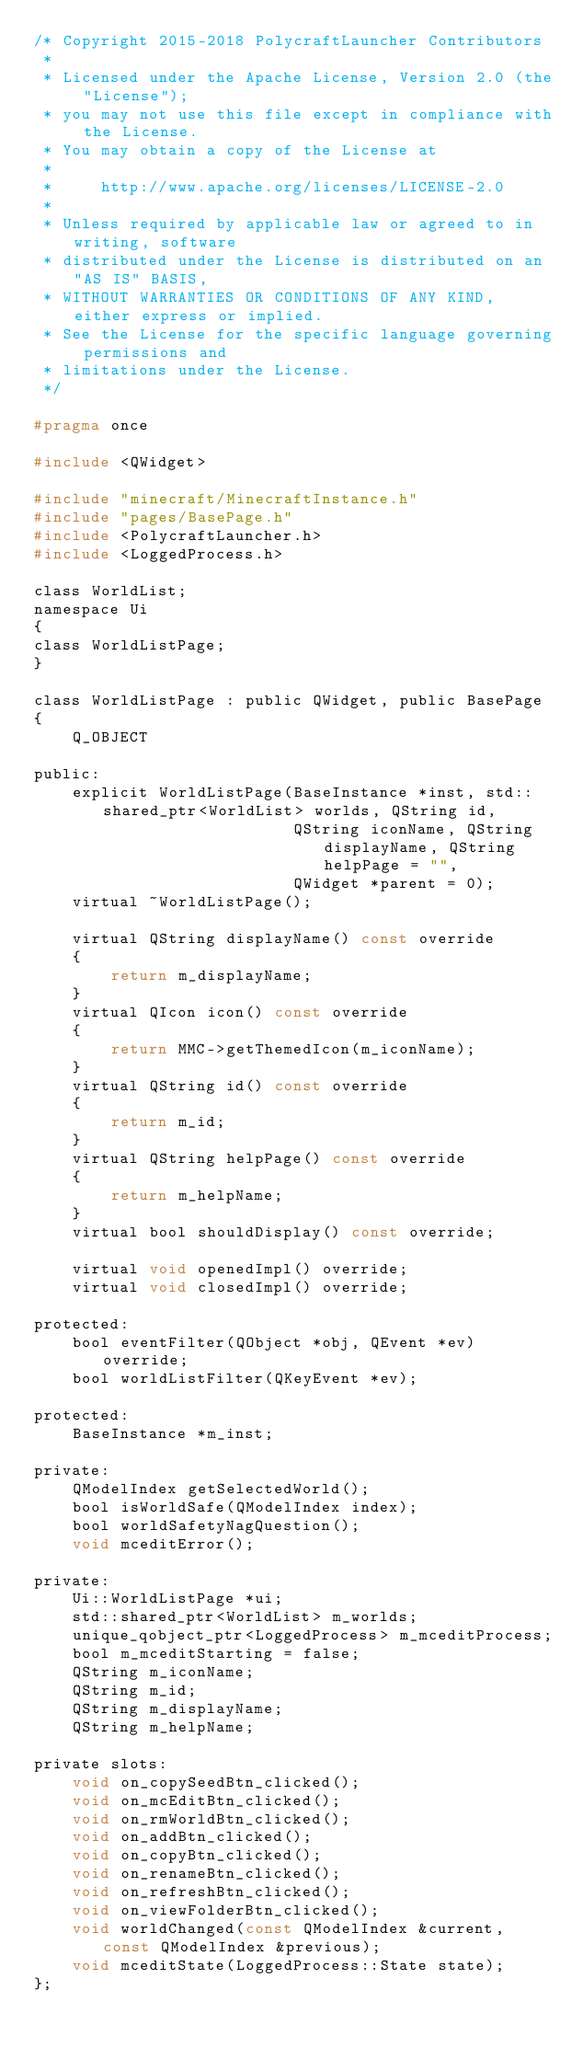<code> <loc_0><loc_0><loc_500><loc_500><_C_>/* Copyright 2015-2018 PolycraftLauncher Contributors
 *
 * Licensed under the Apache License, Version 2.0 (the "License");
 * you may not use this file except in compliance with the License.
 * You may obtain a copy of the License at
 *
 *     http://www.apache.org/licenses/LICENSE-2.0
 *
 * Unless required by applicable law or agreed to in writing, software
 * distributed under the License is distributed on an "AS IS" BASIS,
 * WITHOUT WARRANTIES OR CONDITIONS OF ANY KIND, either express or implied.
 * See the License for the specific language governing permissions and
 * limitations under the License.
 */

#pragma once

#include <QWidget>

#include "minecraft/MinecraftInstance.h"
#include "pages/BasePage.h"
#include <PolycraftLauncher.h>
#include <LoggedProcess.h>

class WorldList;
namespace Ui
{
class WorldListPage;
}

class WorldListPage : public QWidget, public BasePage
{
    Q_OBJECT

public:
    explicit WorldListPage(BaseInstance *inst, std::shared_ptr<WorldList> worlds, QString id,
                           QString iconName, QString displayName, QString helpPage = "",
                           QWidget *parent = 0);
    virtual ~WorldListPage();

    virtual QString displayName() const override
    {
        return m_displayName;
    }
    virtual QIcon icon() const override
    {
        return MMC->getThemedIcon(m_iconName);
    }
    virtual QString id() const override
    {
        return m_id;
    }
    virtual QString helpPage() const override
    {
        return m_helpName;
    }
    virtual bool shouldDisplay() const override;

    virtual void openedImpl() override;
    virtual void closedImpl() override;

protected:
    bool eventFilter(QObject *obj, QEvent *ev) override;
    bool worldListFilter(QKeyEvent *ev);

protected:
    BaseInstance *m_inst;

private:
    QModelIndex getSelectedWorld();
    bool isWorldSafe(QModelIndex index);
    bool worldSafetyNagQuestion();
    void mceditError();

private:
    Ui::WorldListPage *ui;
    std::shared_ptr<WorldList> m_worlds;
    unique_qobject_ptr<LoggedProcess> m_mceditProcess;
    bool m_mceditStarting = false;
    QString m_iconName;
    QString m_id;
    QString m_displayName;
    QString m_helpName;

private slots:
    void on_copySeedBtn_clicked();
    void on_mcEditBtn_clicked();
    void on_rmWorldBtn_clicked();
    void on_addBtn_clicked();
    void on_copyBtn_clicked();
    void on_renameBtn_clicked();
    void on_refreshBtn_clicked();
    void on_viewFolderBtn_clicked();
    void worldChanged(const QModelIndex &current, const QModelIndex &previous);
    void mceditState(LoggedProcess::State state);
};
</code> 